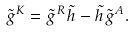<formula> <loc_0><loc_0><loc_500><loc_500>\tilde { g } ^ { K } = \tilde { g } ^ { R } \tilde { h } - \tilde { h } \tilde { g } ^ { A } .</formula> 